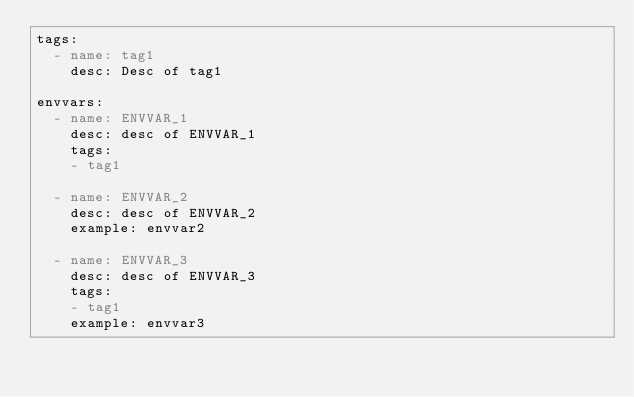Convert code to text. <code><loc_0><loc_0><loc_500><loc_500><_YAML_>tags:
  - name: tag1
    desc: Desc of tag1

envvars:
  - name: ENVVAR_1
    desc: desc of ENVVAR_1
    tags:
    - tag1

  - name: ENVVAR_2
    desc: desc of ENVVAR_2
    example: envvar2

  - name: ENVVAR_3
    desc: desc of ENVVAR_3
    tags:
    - tag1
    example: envvar3</code> 